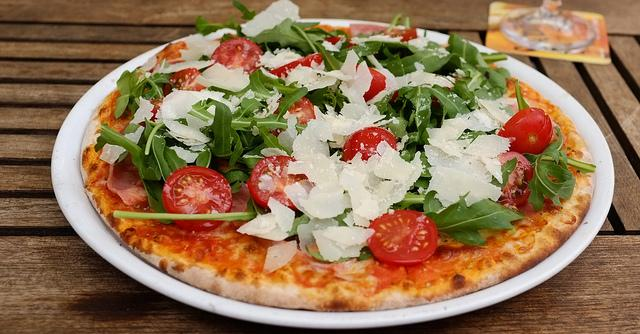Why would someone sit at this table? to eat 